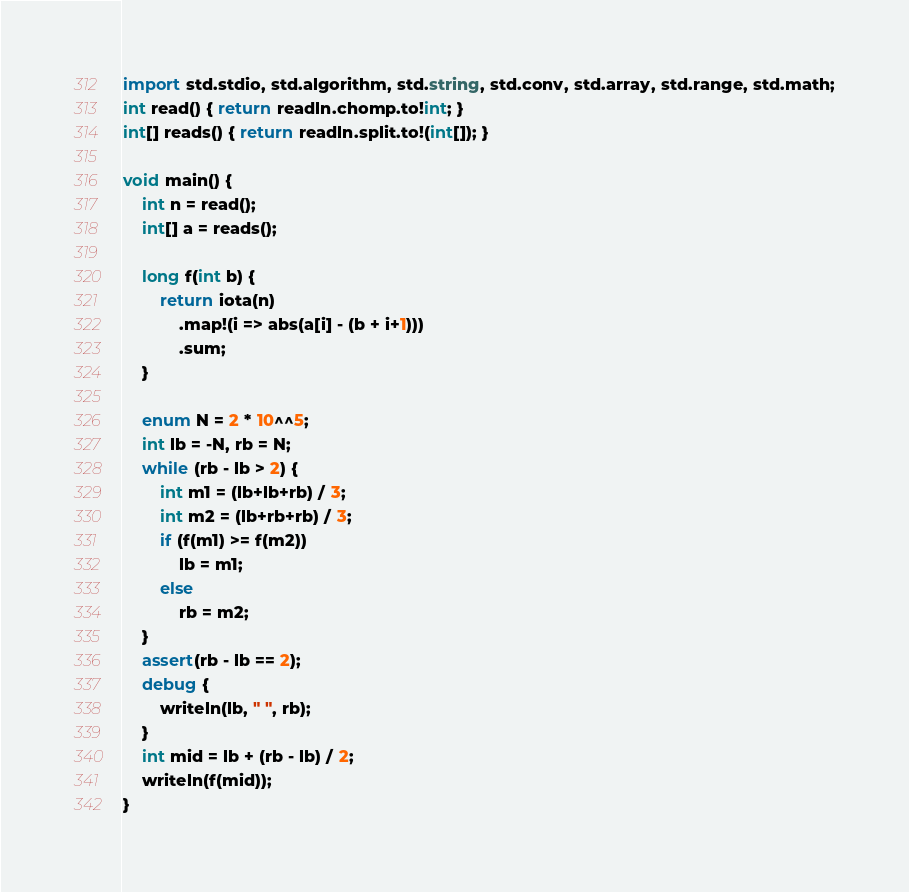Convert code to text. <code><loc_0><loc_0><loc_500><loc_500><_D_>import std.stdio, std.algorithm, std.string, std.conv, std.array, std.range, std.math;
int read() { return readln.chomp.to!int; }
int[] reads() { return readln.split.to!(int[]); }

void main() {
    int n = read();
    int[] a = reads();

    long f(int b) {
        return iota(n)
            .map!(i => abs(a[i] - (b + i+1)))
            .sum;
    }

    enum N = 2 * 10^^5;
    int lb = -N, rb = N;
    while (rb - lb > 2) {
        int m1 = (lb+lb+rb) / 3;
        int m2 = (lb+rb+rb) / 3;
        if (f(m1) >= f(m2))
            lb = m1;
        else
            rb = m2;
    }
    assert(rb - lb == 2);
    debug {
        writeln(lb, " ", rb);
    }
    int mid = lb + (rb - lb) / 2;
    writeln(f(mid));
}</code> 